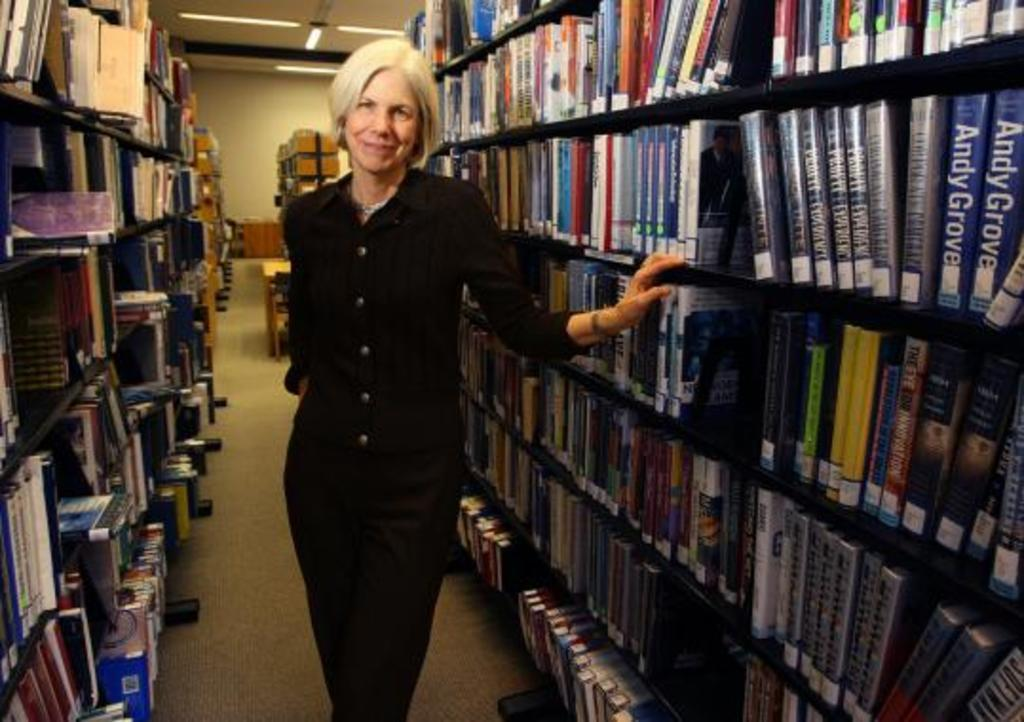<image>
Render a clear and concise summary of the photo. a woman with a library of books, one book says Andy Grove. 